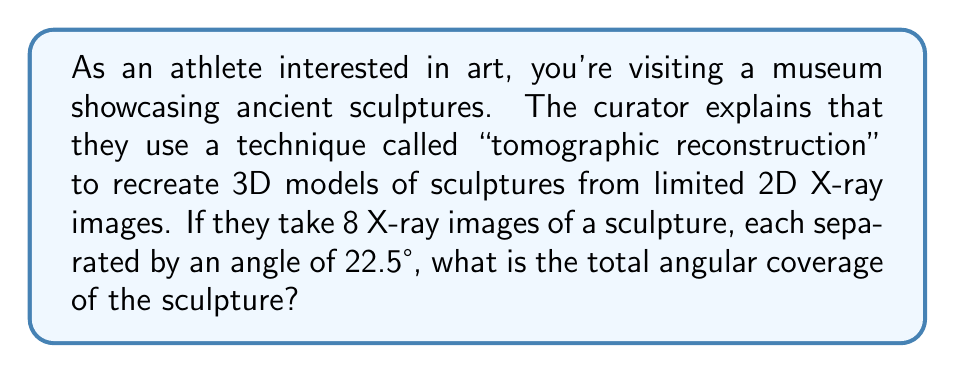Could you help me with this problem? Let's approach this step-by-step:

1) First, we need to understand what the question is asking. We're looking for the total angular coverage of the sculpture based on the X-ray images taken.

2) We're given two key pieces of information:
   - The number of X-ray images: 8
   - The angle between each image: 22.5°

3) To find the total angular coverage, we need to multiply the number of intervals between images by the angle between each image.

4) The number of intervals is one less than the number of images. So with 8 images, there are 7 intervals.

5) We can express this mathematically as:

   $$\text{Total Angular Coverage} = (\text{Number of Intervals}) \times (\text{Angle Between Images})$$

   $$= (8 - 1) \times 22.5°$$

6) Let's calculate:

   $$= 7 \times 22.5°$$
   $$= 157.5°$$

Therefore, the total angular coverage of the sculpture is 157.5°.
Answer: 157.5° 